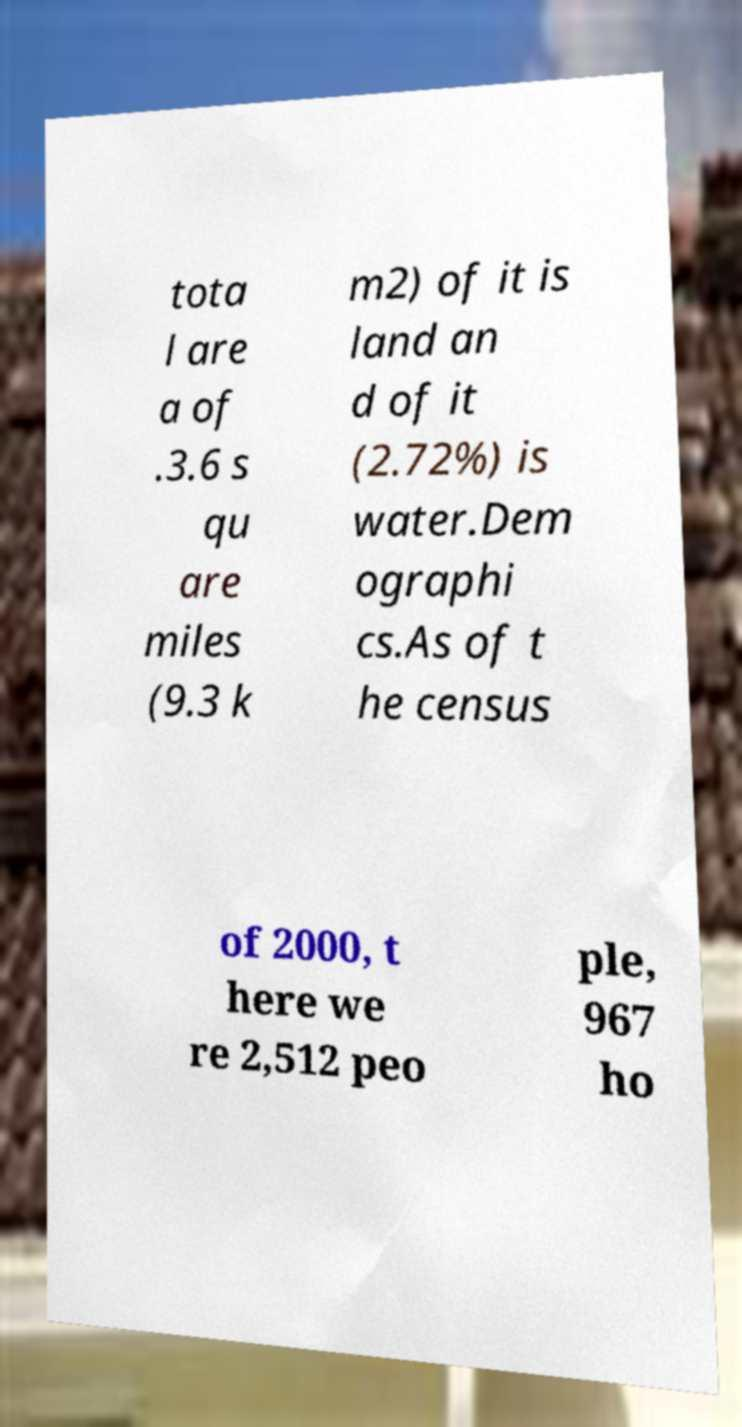Please read and relay the text visible in this image. What does it say? tota l are a of .3.6 s qu are miles (9.3 k m2) of it is land an d of it (2.72%) is water.Dem ographi cs.As of t he census of 2000, t here we re 2,512 peo ple, 967 ho 